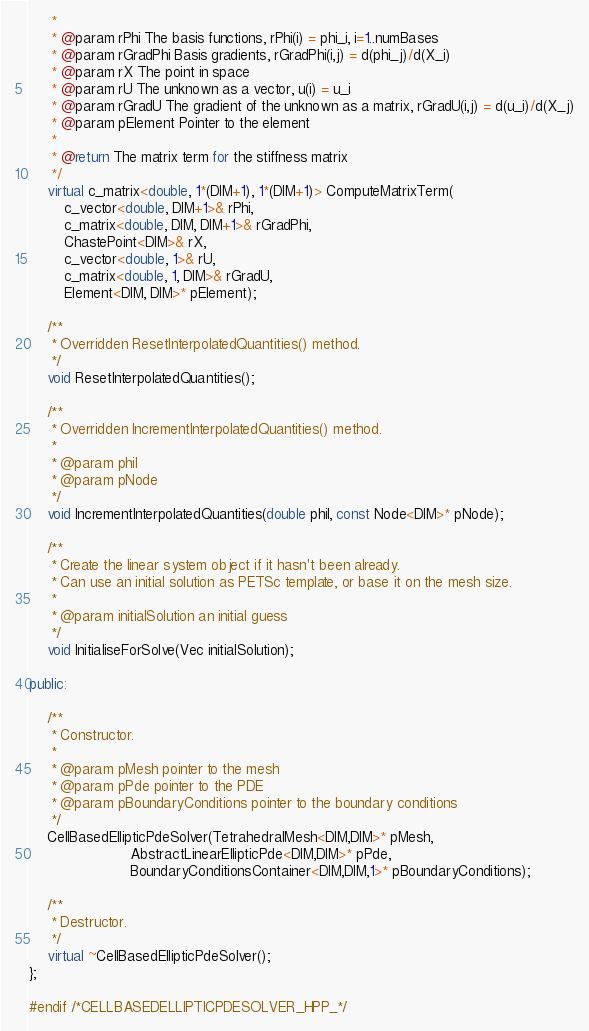Convert code to text. <code><loc_0><loc_0><loc_500><loc_500><_C++_>     *
     * @param rPhi The basis functions, rPhi(i) = phi_i, i=1..numBases
     * @param rGradPhi Basis gradients, rGradPhi(i,j) = d(phi_j)/d(X_i)
     * @param rX The point in space
     * @param rU The unknown as a vector, u(i) = u_i
     * @param rGradU The gradient of the unknown as a matrix, rGradU(i,j) = d(u_i)/d(X_j)
     * @param pElement Pointer to the element
     *
     * @return The matrix term for the stiffness matrix
     */
    virtual c_matrix<double, 1*(DIM+1), 1*(DIM+1)> ComputeMatrixTerm(
        c_vector<double, DIM+1>& rPhi,
        c_matrix<double, DIM, DIM+1>& rGradPhi,
        ChastePoint<DIM>& rX,
        c_vector<double, 1>& rU,
        c_matrix<double, 1, DIM>& rGradU,
        Element<DIM, DIM>* pElement);

    /**
     * Overridden ResetInterpolatedQuantities() method.
     */
    void ResetInterpolatedQuantities();

    /**
     * Overridden IncrementInterpolatedQuantities() method.
     *
     * @param phiI
     * @param pNode
     */
    void IncrementInterpolatedQuantities(double phiI, const Node<DIM>* pNode);

    /**
     * Create the linear system object if it hasn't been already.
     * Can use an initial solution as PETSc template, or base it on the mesh size.
     *
     * @param initialSolution an initial guess
     */
    void InitialiseForSolve(Vec initialSolution);

public:

    /**
     * Constructor.
     *
     * @param pMesh pointer to the mesh
     * @param pPde pointer to the PDE
     * @param pBoundaryConditions pointer to the boundary conditions
     */
    CellBasedEllipticPdeSolver(TetrahedralMesh<DIM,DIM>* pMesh,
                       AbstractLinearEllipticPde<DIM,DIM>* pPde,
                       BoundaryConditionsContainer<DIM,DIM,1>* pBoundaryConditions);

    /**
     * Destructor.
     */
    virtual ~CellBasedEllipticPdeSolver();
};

#endif /*CELLBASEDELLIPTICPDESOLVER_HPP_*/
</code> 